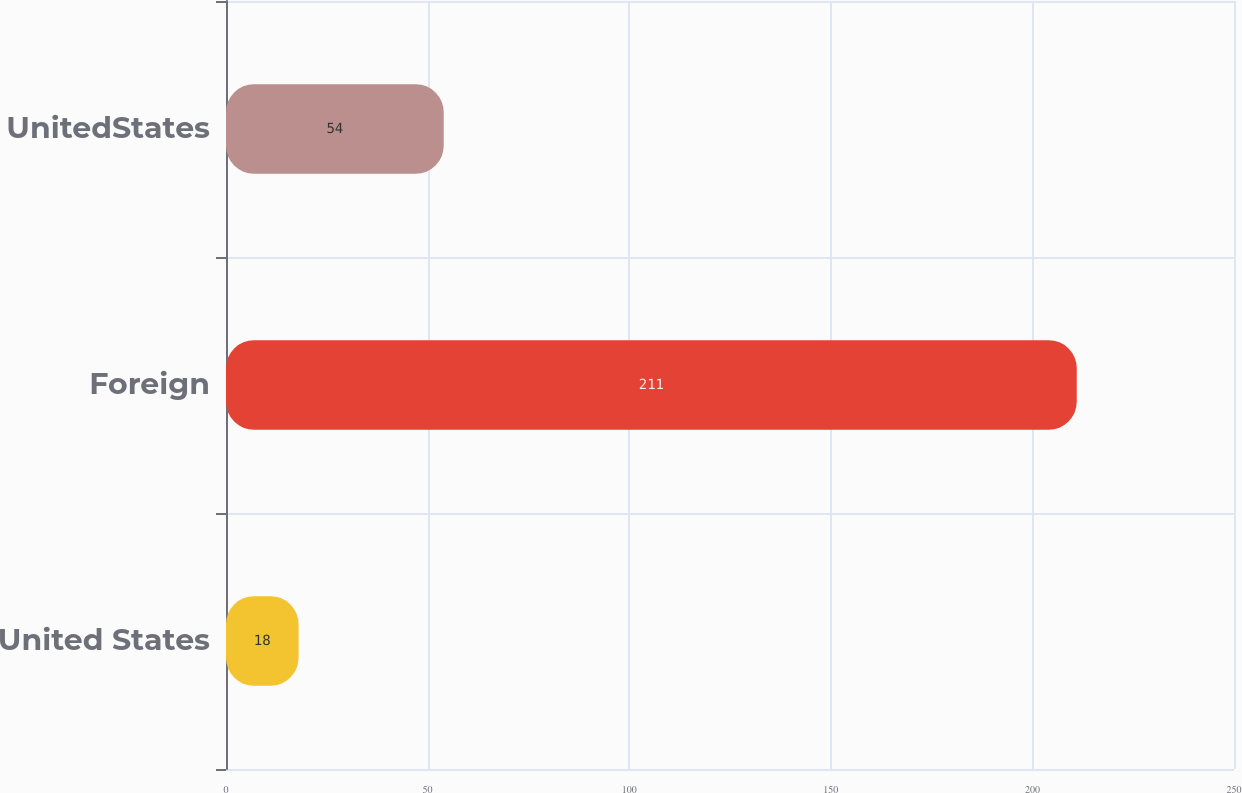<chart> <loc_0><loc_0><loc_500><loc_500><bar_chart><fcel>United States<fcel>Foreign<fcel>UnitedStates<nl><fcel>18<fcel>211<fcel>54<nl></chart> 